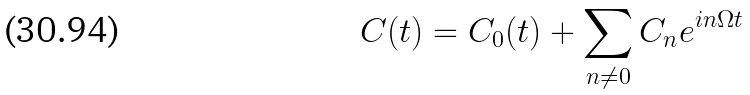<formula> <loc_0><loc_0><loc_500><loc_500>C ( t ) = C _ { 0 } ( t ) + \sum _ { n \ne 0 } C _ { n } e ^ { i n \Omega t }</formula> 